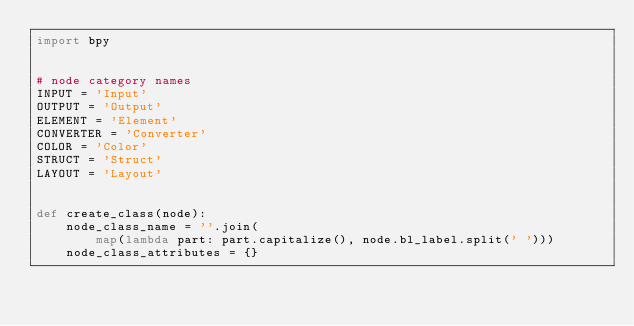<code> <loc_0><loc_0><loc_500><loc_500><_Python_>import bpy


# node category names
INPUT = 'Input'
OUTPUT = 'Output'
ELEMENT = 'Element'
CONVERTER = 'Converter'
COLOR = 'Color'
STRUCT = 'Struct'
LAYOUT = 'Layout'


def create_class(node):
    node_class_name = ''.join(
        map(lambda part: part.capitalize(), node.bl_label.split(' ')))
    node_class_attributes = {}</code> 